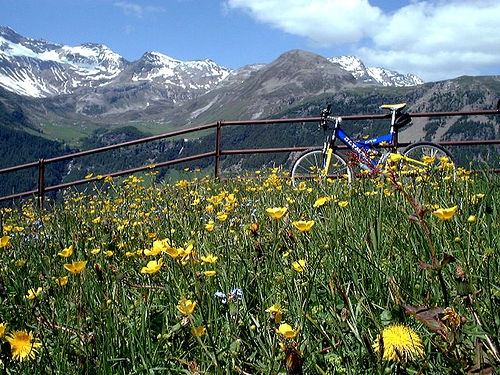Describe the objects in this image and their specific colors. I can see a bicycle in gray, black, white, and darkgray tones in this image. 